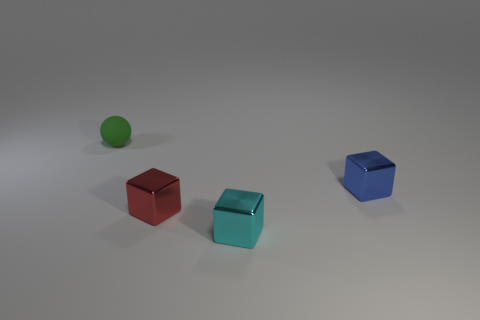Subtract all blue blocks. How many blocks are left? 2 Add 3 large brown balls. How many objects exist? 7 Subtract all balls. How many objects are left? 3 Subtract 0 brown spheres. How many objects are left? 4 Subtract all red cubes. Subtract all gray balls. How many cubes are left? 2 Subtract all blue metal cylinders. Subtract all small cubes. How many objects are left? 1 Add 1 small blue objects. How many small blue objects are left? 2 Add 3 small green objects. How many small green objects exist? 4 